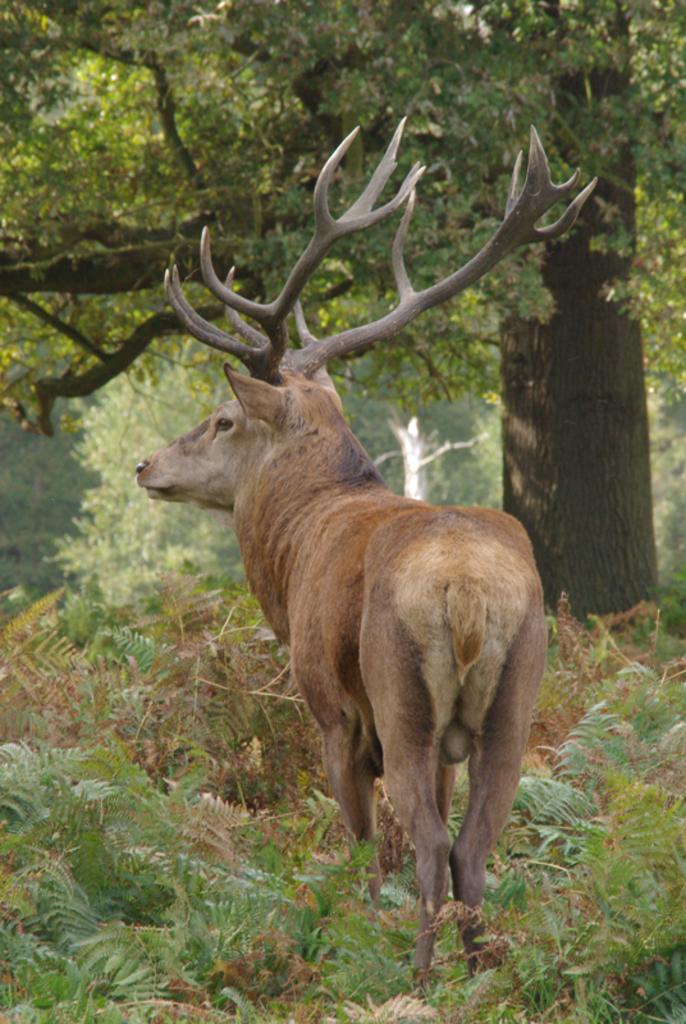What type of animal can be seen on the ground in the image? There is an animal on the ground in the image, but the specific type cannot be determined from the facts provided. What other living organisms are present in the image? There are plants in the image. What part of a tree can be seen in the image? The bark of a tree is visible in the image. How many trees are grouped together in the image? There is a group of trees in the image. What type of leather can be seen on the animal in the image? There is no leather present on the animal in the image, as the facts provided do not mention any such material. What was the afterthought when creating the image? The facts provided do not give any information about the creator's intentions or thought process, so it is impossible to determine any afterthoughts. 